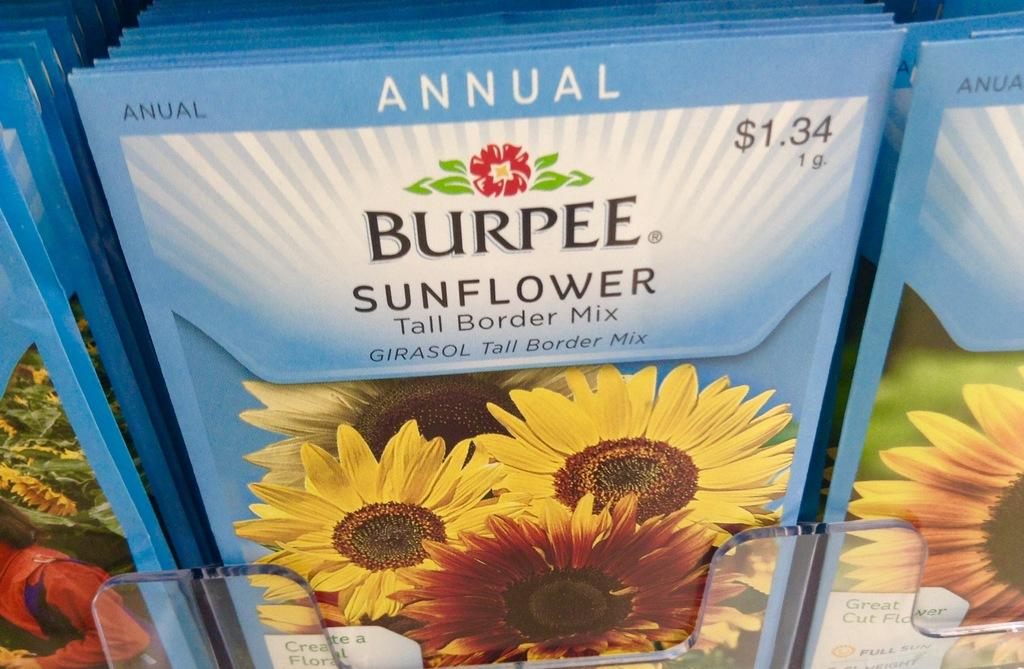What color are the packets in the image? The packets in the image are blue. What images are on the packets? The packets have sunflower images on them. What type of drum can be seen in the wilderness in the image? There is no drum or wilderness present in the image; it only features blue color packets with sunflower images. Can you describe the taste of the packets in the image? The taste of the packets cannot be determined from the image, as taste is not a visual characteristic. 